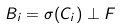Convert formula to latex. <formula><loc_0><loc_0><loc_500><loc_500>B _ { i } = \sigma ( C _ { i } ) \perp F</formula> 